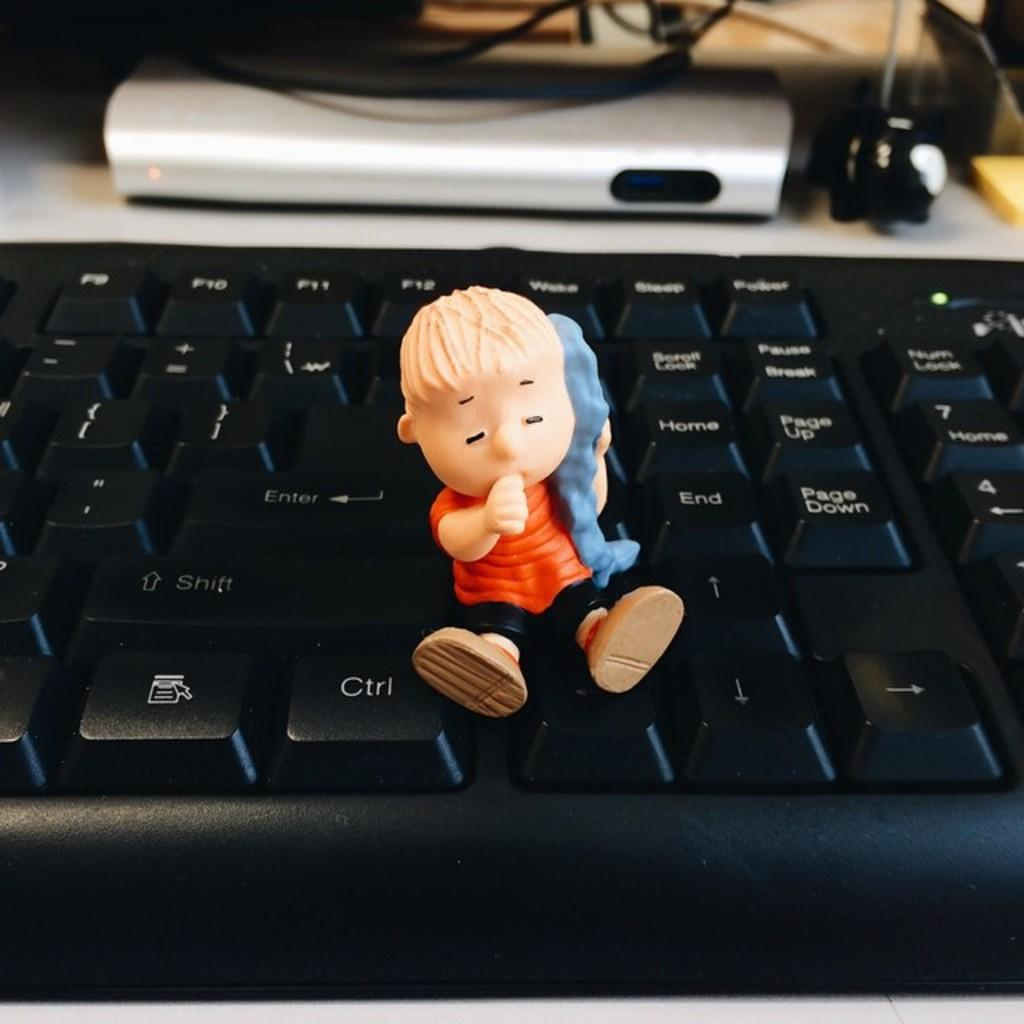What is the main piece of furniture in the image? There is a table in the image. What is placed on the table? A keyboard and a device are placed on the table. Are there any additional items on the table? Yes, cables are present on the table. What is the toy doing on the keyboard? The toy is placed on the keyboard. How many legs can be seen on the road in the image? There is no road present in the image, and therefore no legs can be seen on a road. 